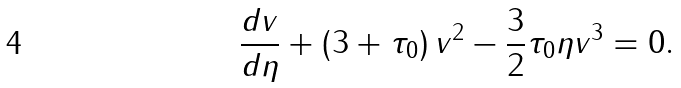Convert formula to latex. <formula><loc_0><loc_0><loc_500><loc_500>\frac { d v } { d \eta } + \left ( 3 + \tau _ { 0 } \right ) v ^ { 2 } - \frac { 3 } { 2 } \tau _ { 0 } \eta v ^ { 3 } = 0 .</formula> 